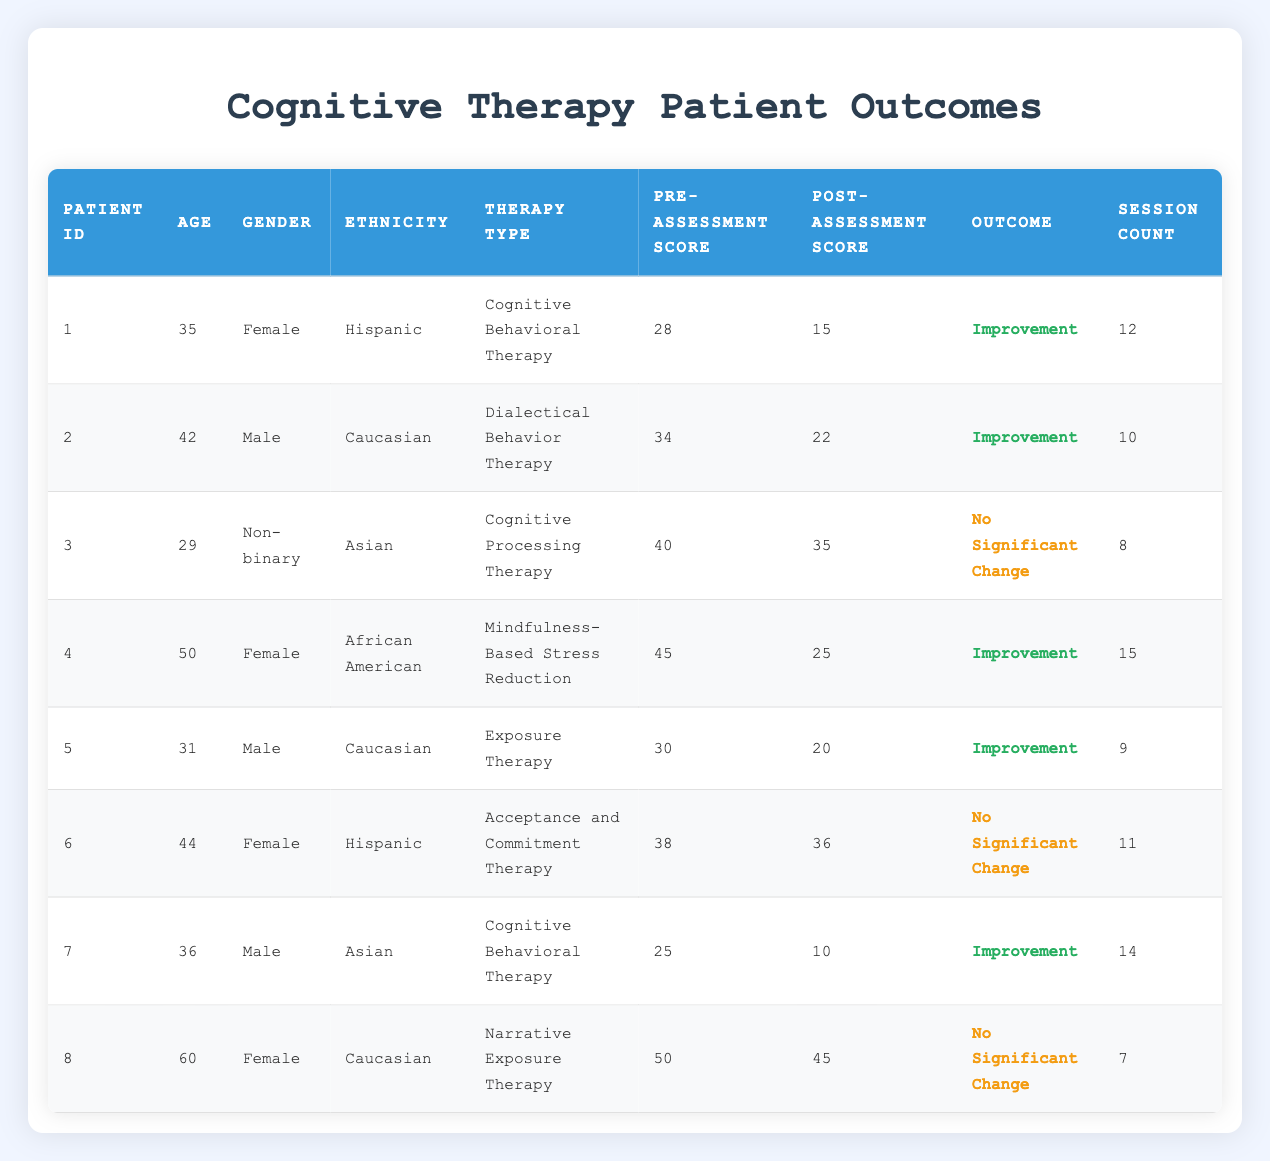What is the pre-assessment score of Patient ID 4? The table indicates that Patient ID 4 has a pre-assessment score of 45 in the corresponding column.
Answer: 45 How many patients demonstrated improvement after therapy? By reviewing the "Outcome" column, we see that there are five "Improvement" entries for Patients IDs 1, 2, 4, 5, and 7. Thus, the count is 5.
Answer: 5 What is the average age of patients who experienced no significant change? There are two patients with "No Significant Change" outcomes (Patient IDs 3 and 6). Their ages are 29 and 44, respectively. To find the average, we add 29 + 44 = 73 and divide by 2, resulting in 73 / 2 = 36.5.
Answer: 36.5 Was any patient using Cognitive Behavioral Therapy classified as having no significant change? Looking at the therapy type for all patients, Patient ID 3, who underwent Cognitive Processing Therapy, is the only individual without improvement. Hence, no patient using Cognitive Behavioral Therapy had no significant change.
Answer: No What is the difference between the highest and lowest post-assessment scores? The highest post-assessment score is 45 (Patient ID 8), and the lowest is 10 (Patient ID 7). Calculating the difference gives us 45 - 10 = 35.
Answer: 35 How many sessions did the average male patient undergo? There are three male patients: IDs 2, 5, and 7. The session counts are 10, 9, and 14, respectively. Summing these gives 10 + 9 + 14 = 33, and the average is 33 / 3 = 11.
Answer: 11 Are there any patients over the age of 50 who showed improvement? Reviewing the table, Patient ID 4 is aged 50 and experienced improvement, but no others are over that age. Thus, the answer is yes.
Answer: Yes What is the ethnicity of the patient with the highest pre-assessment score? Observing the pre-assessment scores, Patient ID 4 has the highest score of 45 and is categorized as African American.
Answer: African American 